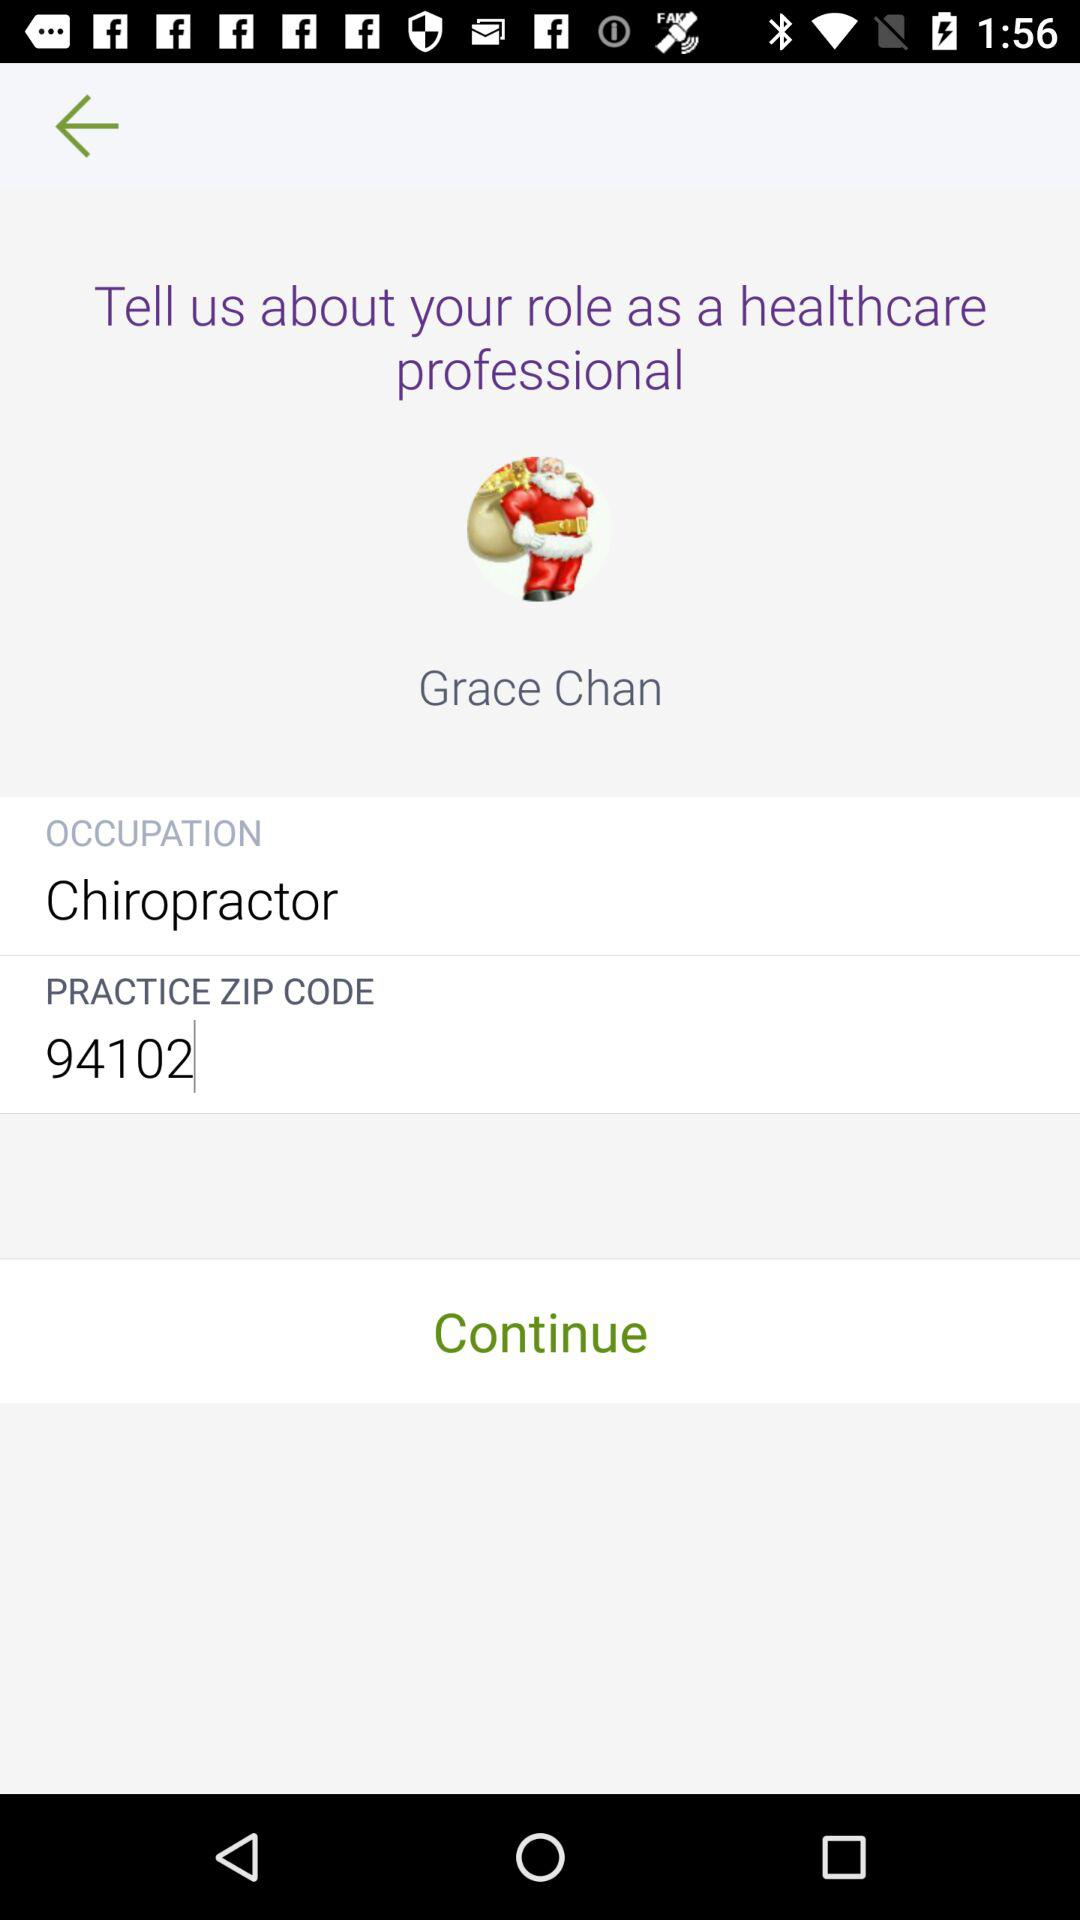What is the practice ZIP code? The practice ZIP code is 94102. 